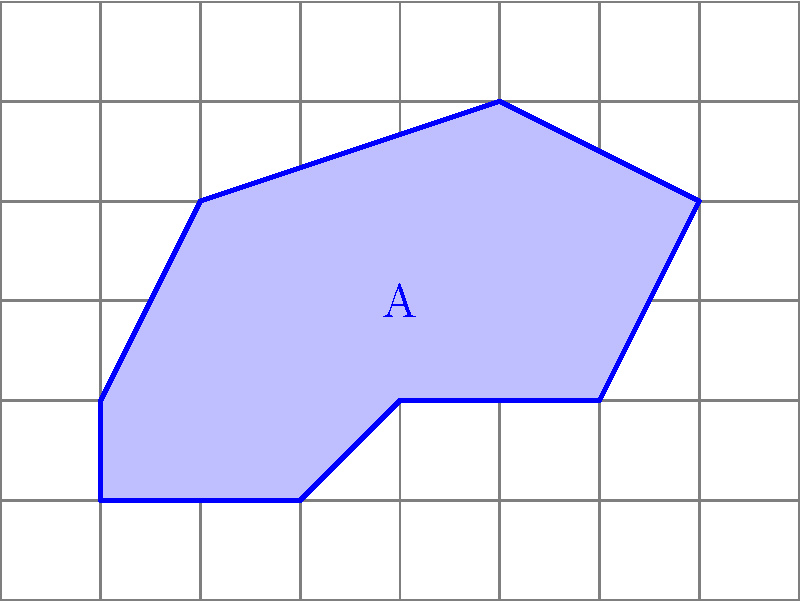Your child is working on an advanced geometry project and needs help calculating the area of an irregular shape. The shape is drawn on a grid where each square represents 1 square unit. How would you guide your child to determine the area of the blue shape labeled 'A' as accurately as possible using the grid system? To guide your child in determining the area of the irregular shape using the grid system, follow these steps:

1. Explain that each full square within the shape counts as 1 square unit.

2. For partial squares, estimate whether they are closer to 1/4, 1/2, or 3/4 of a full square.

3. Count the full squares within the shape:
   There are approximately 15 full squares.

4. Estimate the partial squares:
   - There are about 4 squares that are roughly 3/4 full
   - There are about 6 squares that are roughly 1/2 full
   - There are about 2 squares that are roughly 1/4 full

5. Calculate the total area:
   $$ \text{Area} = 15 + (4 \times \frac{3}{4}) + (6 \times \frac{1}{2}) + (2 \times \frac{1}{4}) $$
   $$ = 15 + 3 + 3 + 0.5 $$
   $$ = 21.5 \text{ square units} $$

6. Explain that this method provides an approximation, and the accuracy can be improved by using a finer grid or more precise measuring tools.
Answer: Approximately 21.5 square units 